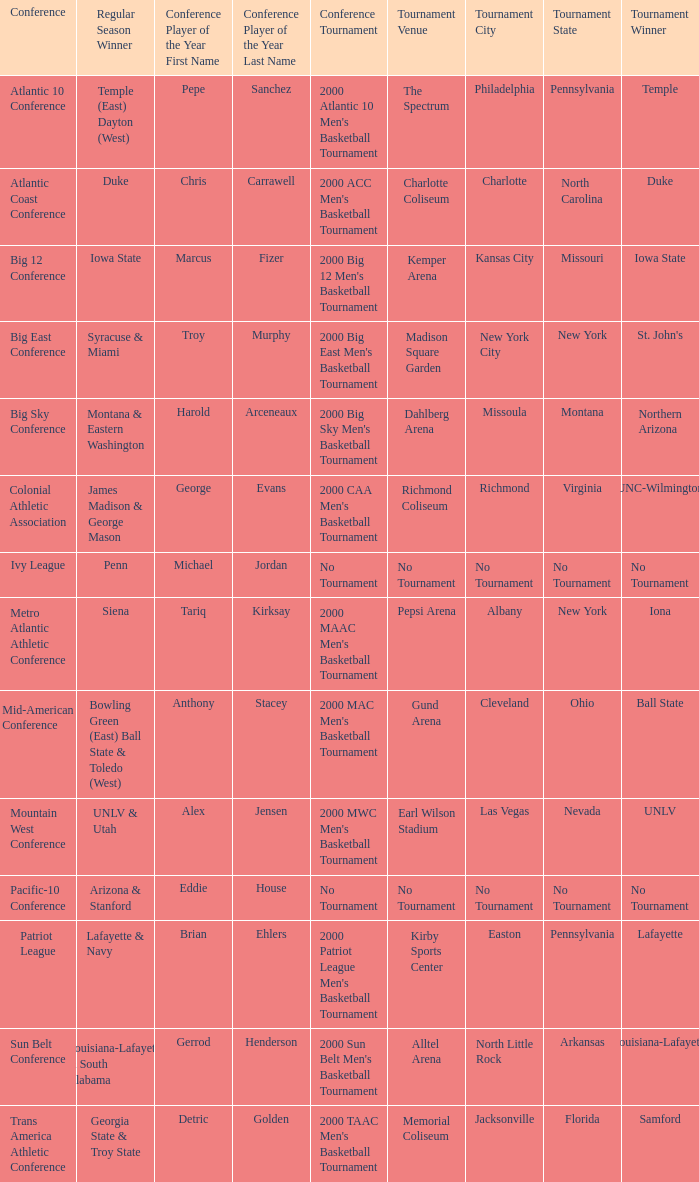Who is the regular season winner for the Ivy League conference? Penn. 